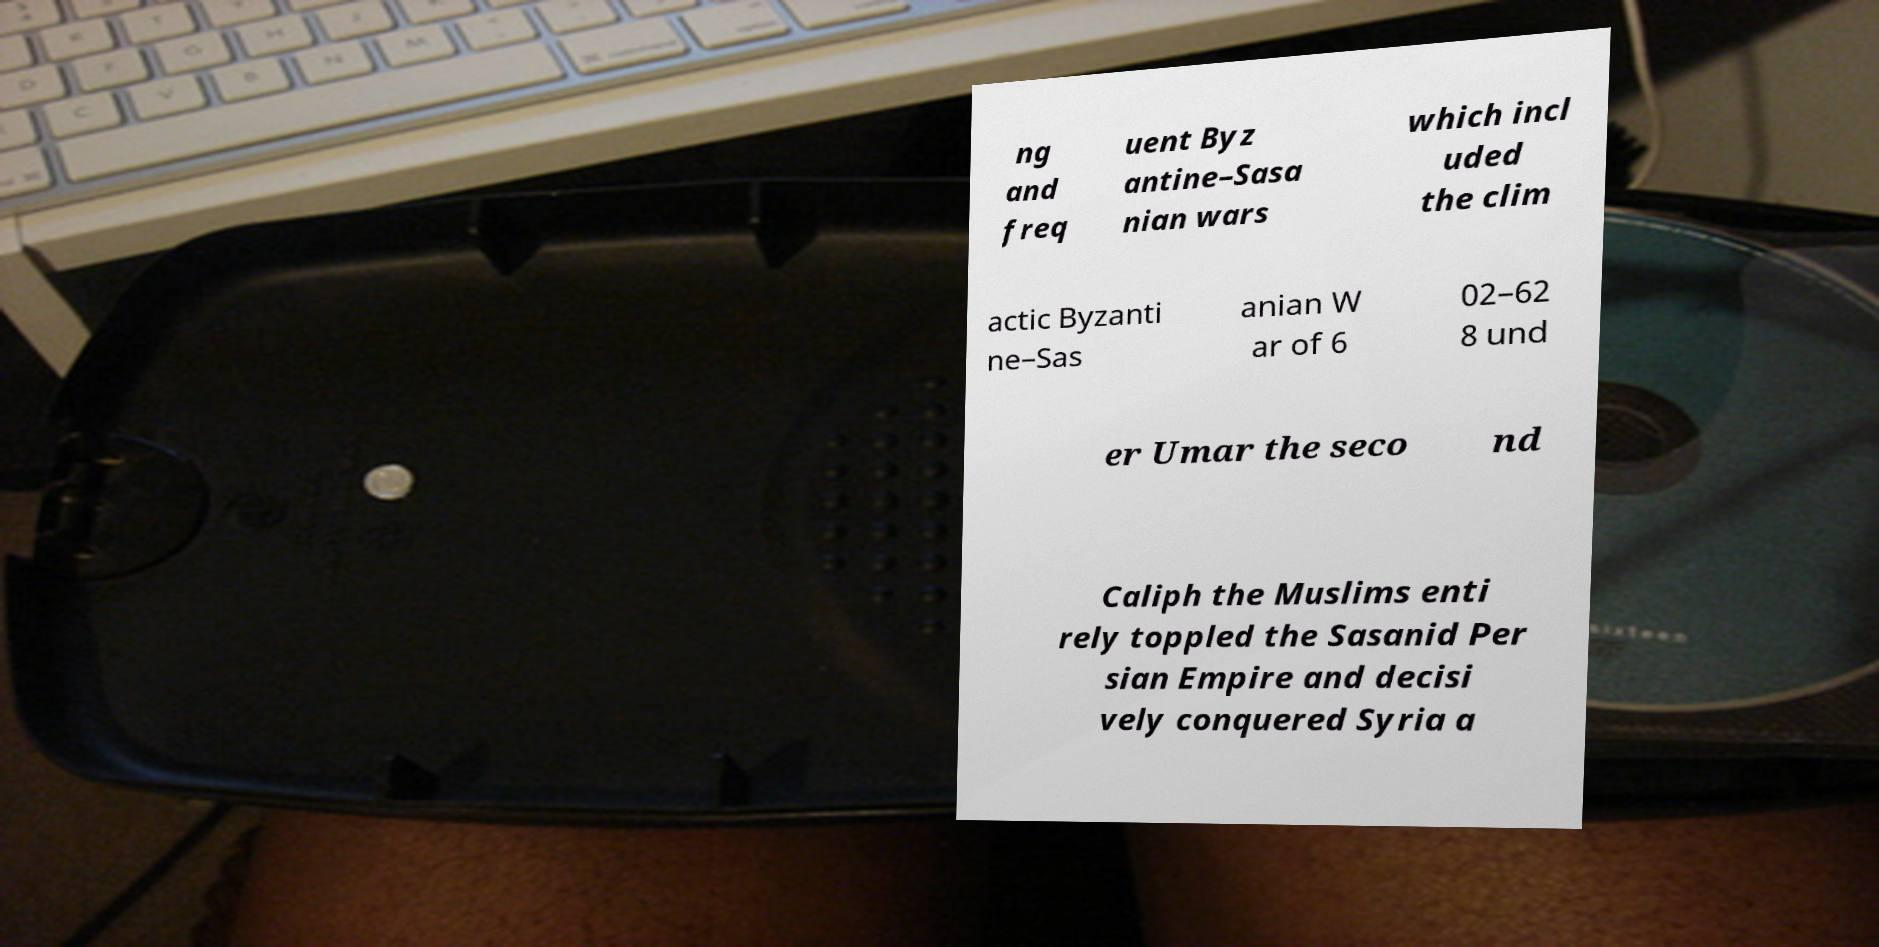Please read and relay the text visible in this image. What does it say? ng and freq uent Byz antine–Sasa nian wars which incl uded the clim actic Byzanti ne–Sas anian W ar of 6 02–62 8 und er Umar the seco nd Caliph the Muslims enti rely toppled the Sasanid Per sian Empire and decisi vely conquered Syria a 